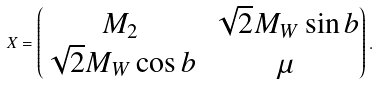Convert formula to latex. <formula><loc_0><loc_0><loc_500><loc_500>X = \begin{pmatrix} M _ { 2 } & \sqrt { 2 } M _ { W } \sin b \\ \sqrt { 2 } M _ { W } \cos b & \mu \end{pmatrix} .</formula> 